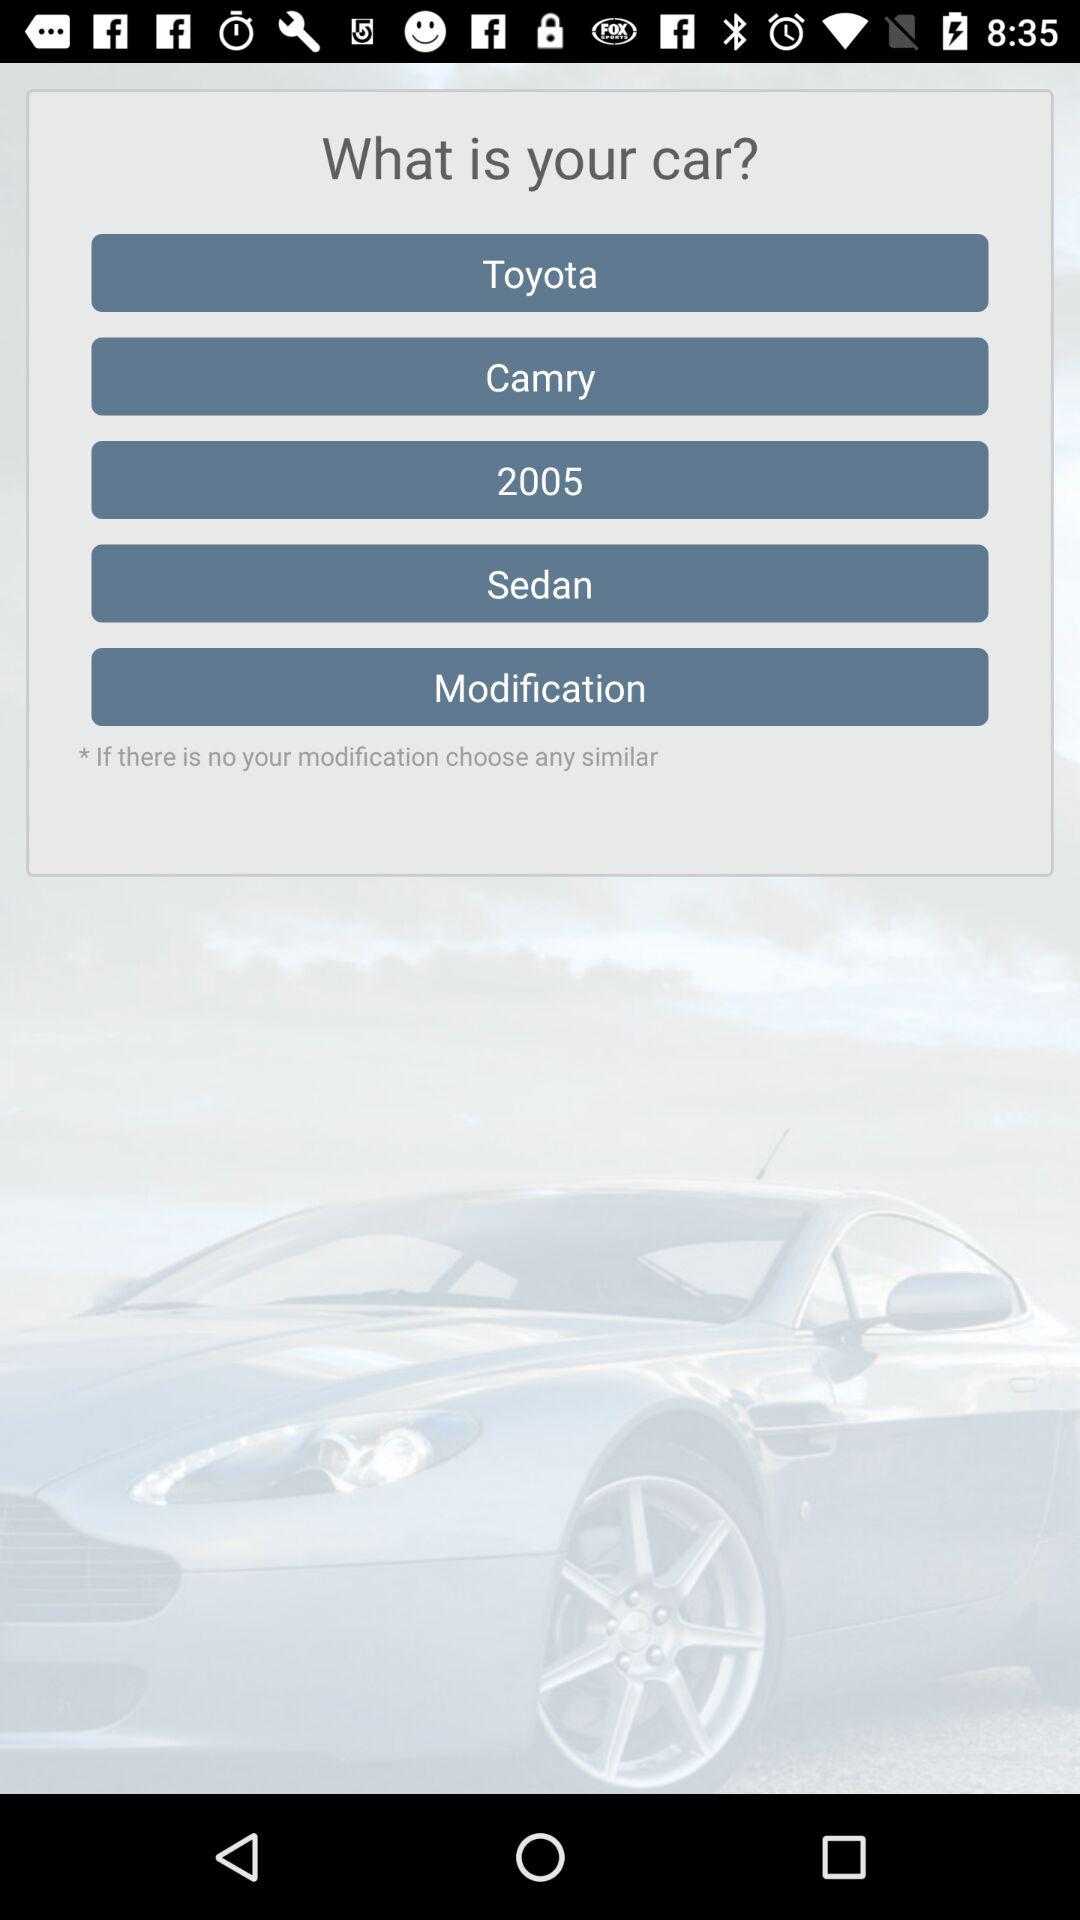How many modification options are there?
Answer the question using a single word or phrase. 1 